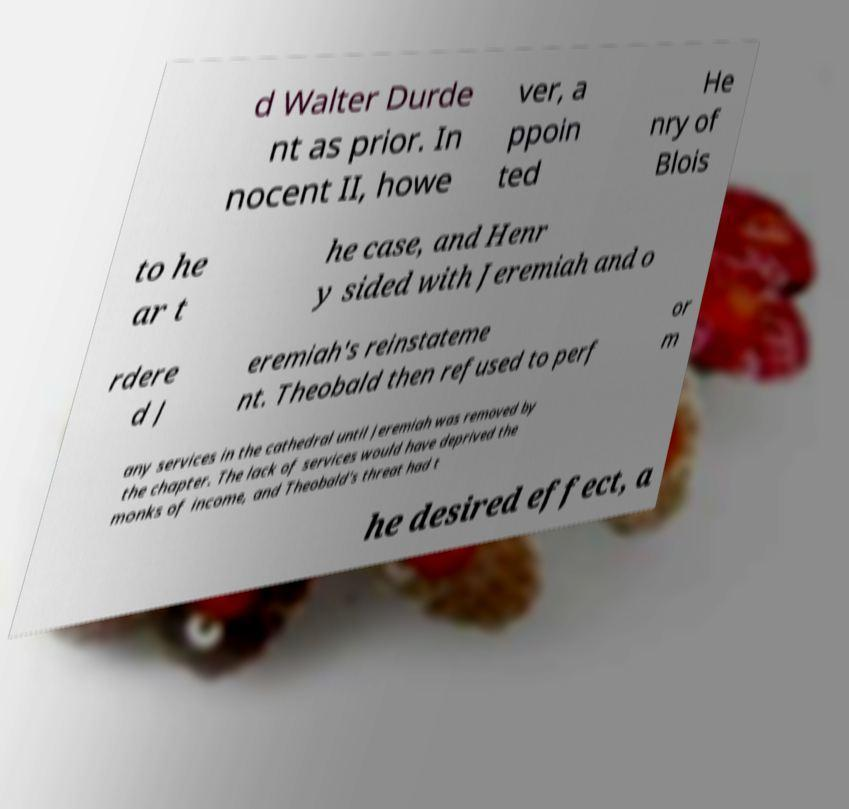What messages or text are displayed in this image? I need them in a readable, typed format. d Walter Durde nt as prior. In nocent II, howe ver, a ppoin ted He nry of Blois to he ar t he case, and Henr y sided with Jeremiah and o rdere d J eremiah's reinstateme nt. Theobald then refused to perf or m any services in the cathedral until Jeremiah was removed by the chapter. The lack of services would have deprived the monks of income, and Theobald's threat had t he desired effect, a 